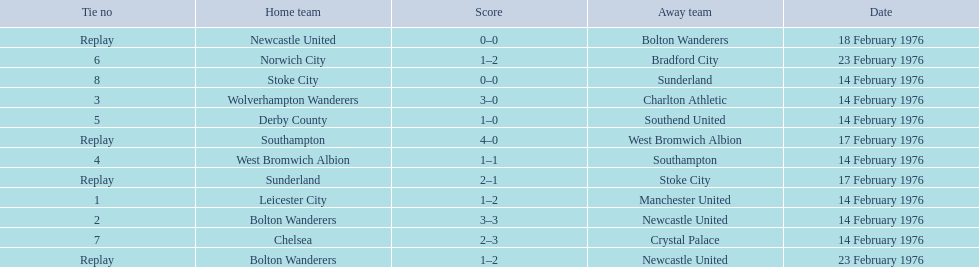What teams are featured in the game at the top of the table? Leicester City, Manchester United. Which of these two is the home team? Leicester City. 